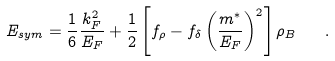Convert formula to latex. <formula><loc_0><loc_0><loc_500><loc_500>E _ { s y m } = \frac { 1 } { 6 } \frac { k _ { F } ^ { 2 } } { E _ { F } } + \frac { 1 } { 2 } \left [ f _ { \rho } - f _ { \delta } \left ( \frac { m ^ { * } } { E _ { F } } \right ) ^ { 2 } \right ] \rho _ { B } \quad .</formula> 